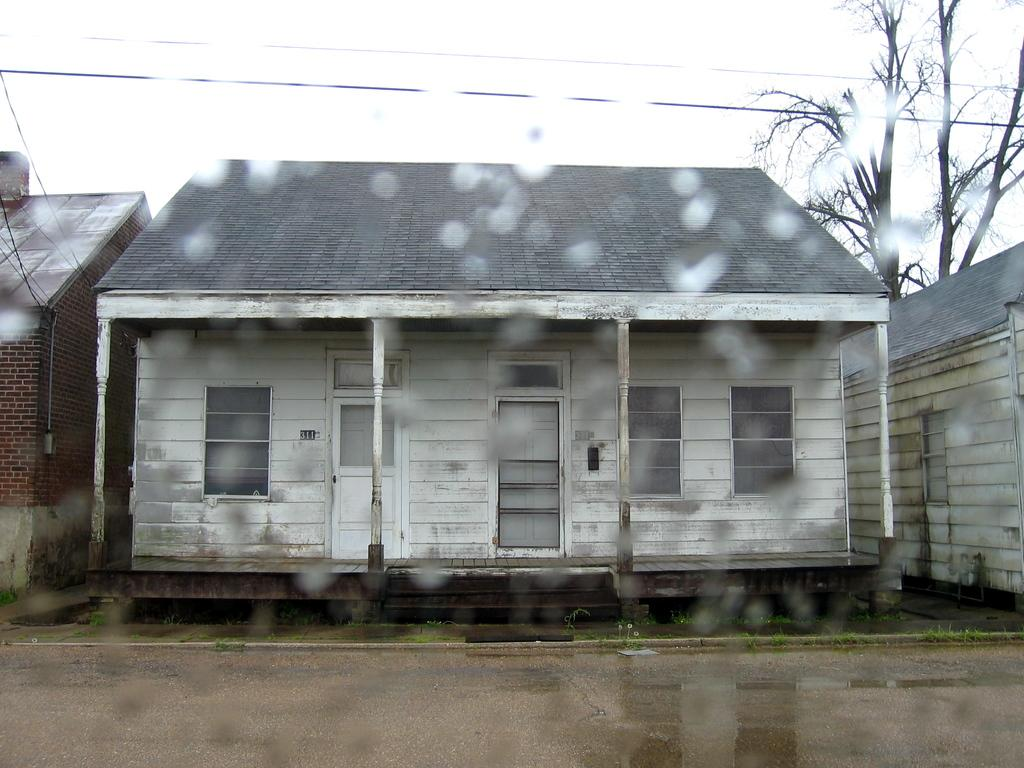What structures are located in the center of the image? There are sheds in the center of the image. What is at the bottom of the image? There is a road at the bottom of the image. What can be seen in the background of the image? There is a tree, wires, and the sky visible in the background of the image. What type of boot is hanging from the tree in the image? There is no boot hanging from the tree in the image; only a tree, wires, and the sky are visible in the background. Does the alarm in the image indicate that it's time to wake up? There is no alarm present in the image. 